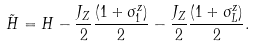<formula> <loc_0><loc_0><loc_500><loc_500>\tilde { H } = H - \frac { J _ { Z } } { 2 } \frac { ( 1 + \sigma _ { 1 } ^ { z } ) } { 2 } - \frac { J _ { Z } } { 2 } \frac { ( 1 + \sigma _ { L } ^ { z } ) } { 2 } .</formula> 